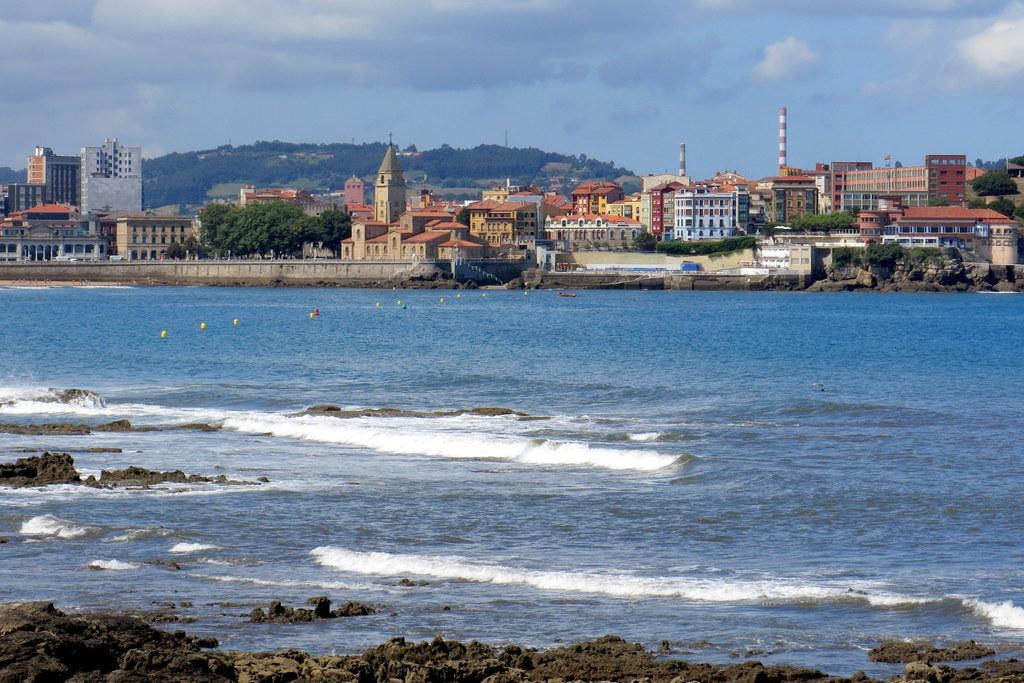How would you summarize this image in a sentence or two? In this picture we can see water at the bottom, in the background there are some buildings and trees, we can also see factory exhaust pipe in the background, there is the sky and clouds at the top of the picture. 